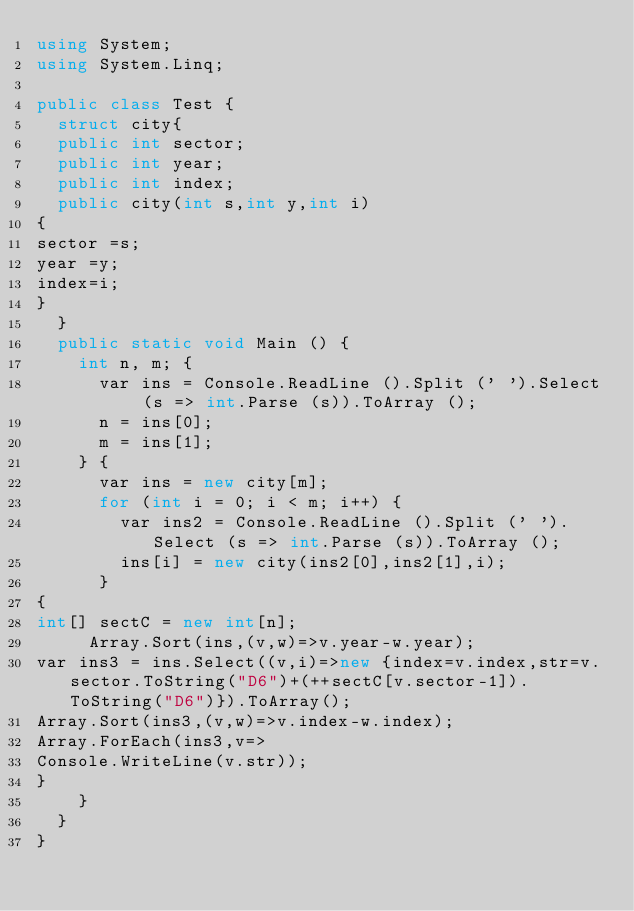Convert code to text. <code><loc_0><loc_0><loc_500><loc_500><_C#_>using System;
using System.Linq;

public class Test {
  struct city{
  public int sector;
  public int year;
  public int index;
  public city(int s,int y,int i)
{
sector =s;
year =y;
index=i;
}
  }
  public static void Main () {
    int n, m; {
      var ins = Console.ReadLine ().Split (' ').Select (s => int.Parse (s)).ToArray ();
      n = ins[0];
      m = ins[1];
    } {
      var ins = new city[m];
      for (int i = 0; i < m; i++) {
        var ins2 = Console.ReadLine ().Split (' ').Select (s => int.Parse (s)).ToArray ();
        ins[i] = new city(ins2[0],ins2[1],i);
      }
{
int[] sectC = new int[n];
     Array.Sort(ins,(v,w)=>v.year-w.year);
var ins3 = ins.Select((v,i)=>new {index=v.index,str=v.sector.ToString("D6")+(++sectC[v.sector-1]).ToString("D6")}).ToArray();
Array.Sort(ins3,(v,w)=>v.index-w.index);
Array.ForEach(ins3,v=>
Console.WriteLine(v.str));
}
    }
  }
}</code> 